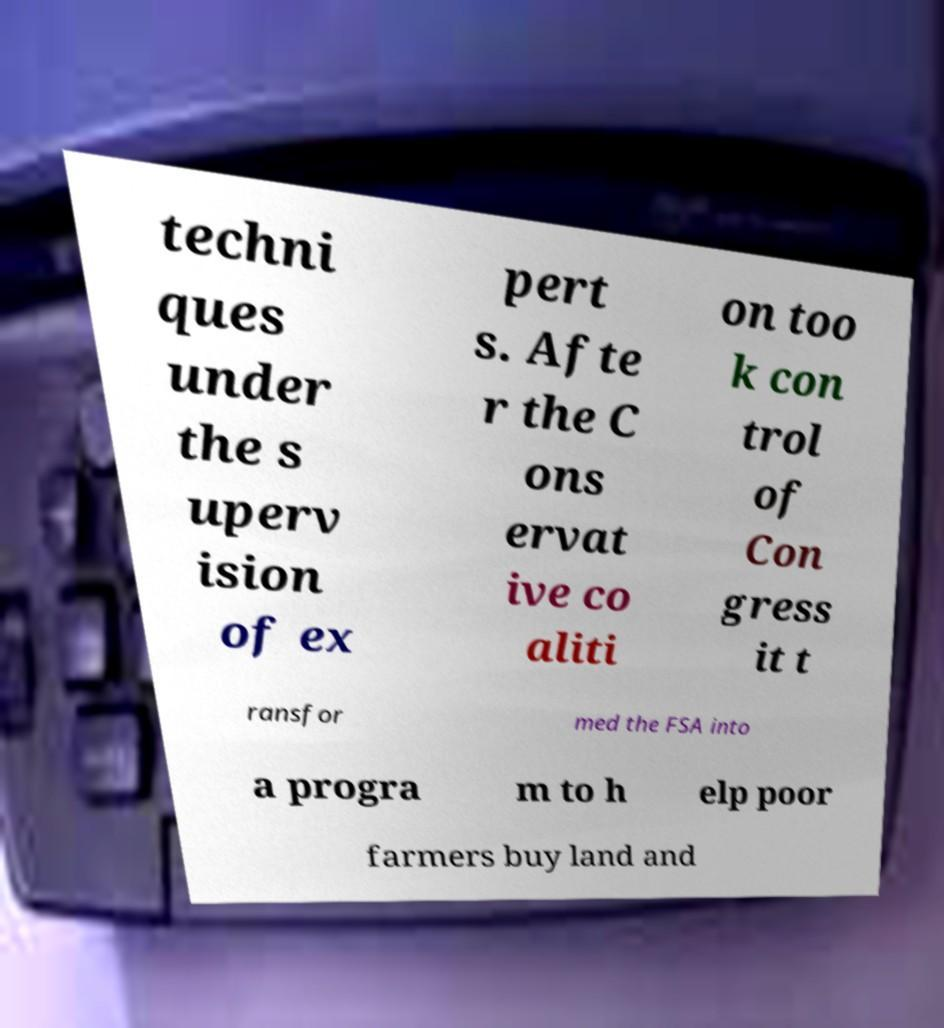Please read and relay the text visible in this image. What does it say? techni ques under the s uperv ision of ex pert s. Afte r the C ons ervat ive co aliti on too k con trol of Con gress it t ransfor med the FSA into a progra m to h elp poor farmers buy land and 